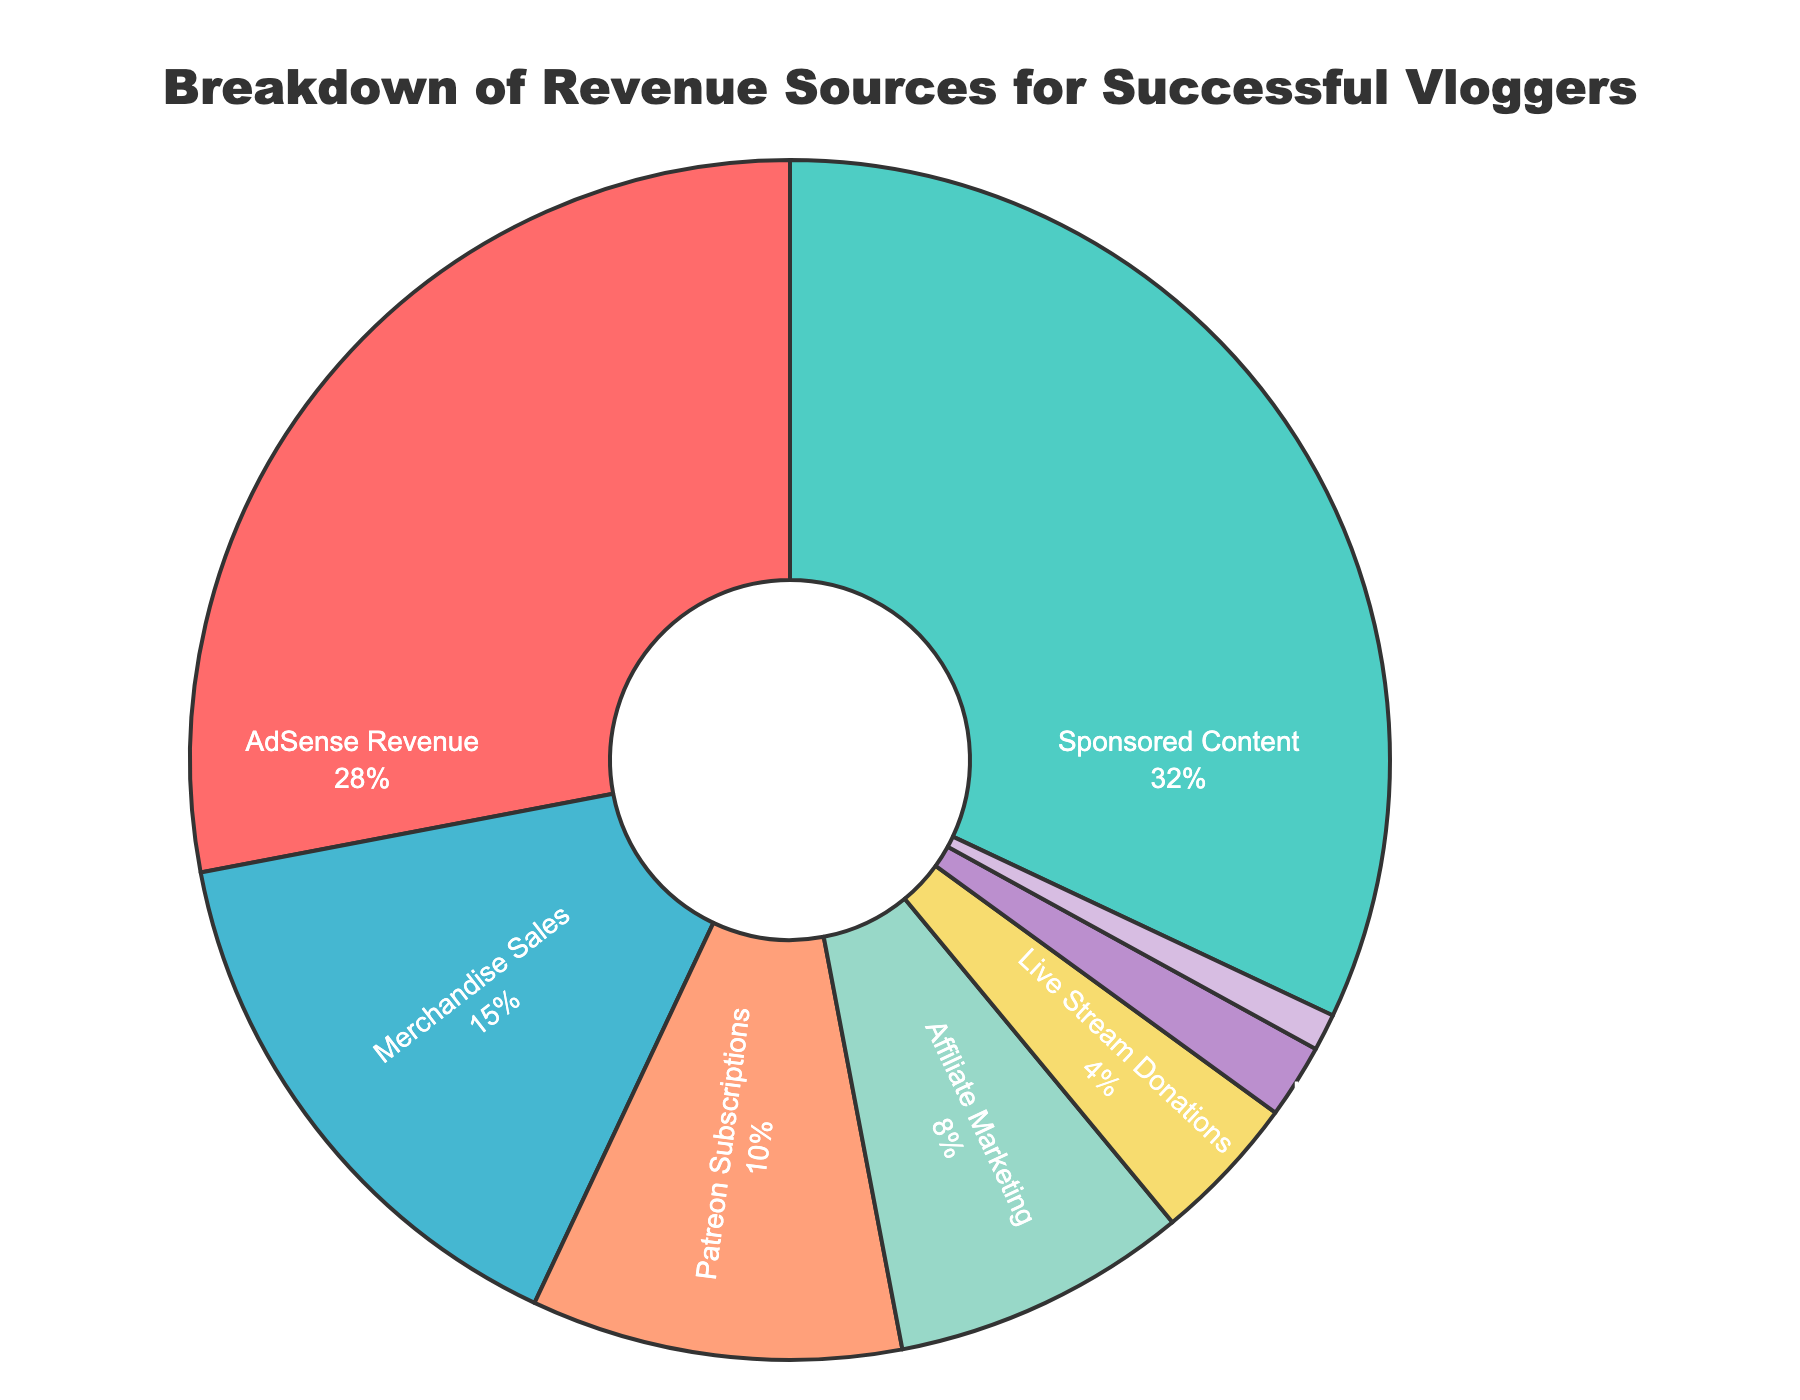What percentage of total revenue comes from merchandise sales and live stream donations combined? To find the combined percentage, add the percentages of merchandise sales and live stream donations: 15% + 4% = 19%.
Answer: 19% Which revenue source contributes more: Patreon subscriptions or affiliate marketing? Compare the percentages of Patreon subscriptions (10%) and affiliate marketing (8%). 10% is greater than 8%, so Patreon subscriptions contribute more.
Answer: Patreon subscriptions What is the second largest revenue source for successful vloggers? Identify the revenue sources and their percentages: Sponsored Content (32%) and AdSense Revenue (28%). The second largest after Sponsored Content is AdSense Revenue.
Answer: AdSense Revenue What fraction of the total revenue is contributed by book deals? Since the total revenue is 100%, the fraction for book deals is 1%. In fractional terms, it is 1/100.
Answer: 1/100 By how much does the percentage of ad revenue exceed that of affiliate marketing? Subtract the percentage of affiliate marketing (8%) from the ad revenue (28%): 28% - 8% = 20%.
Answer: 20% If you were to combine the revenue from speaking engagements and book deals, would it be more than live stream donations? Add percentages of speaking engagements (2%) and book deals (1%) to get 3%. Compare this to live stream donations (4%). Since 3% is less than 4%, the combined revenue is not more than live stream donations.
Answer: No Which revenue source has the smallest contribution? The revenue sources and their percentages are reviewed. The source with the smallest percentage is Book Deals at 1%.
Answer: Book Deals Compare the total percentage of ad revenue, sponsored content, and merchandise sales to the rest of the revenue sources. Which group is larger? First, calculate the total percentage for ad revenue (28%), sponsored content (32%), and merchandise sales (15%): 28% + 32% + 15% = 75%. The rest of the revenue sources total to 100% - 75% = 25%. Hence, ad revenue, sponsored content, and merchandise sales combined contribute more.
Answer: Ad revenue, sponsored content, and merchandise sales How many revenue sources contribute 5% or more individually? Look at the percentages for each revenue source. AdSense Revenue (28%), Sponsored Content (32%), Merchandise Sales (15%), Patreon Subscriptions (10%), and Affiliate Marketing (8%) all contribute 5% or more. There are 5 revenue sources.
Answer: 5 